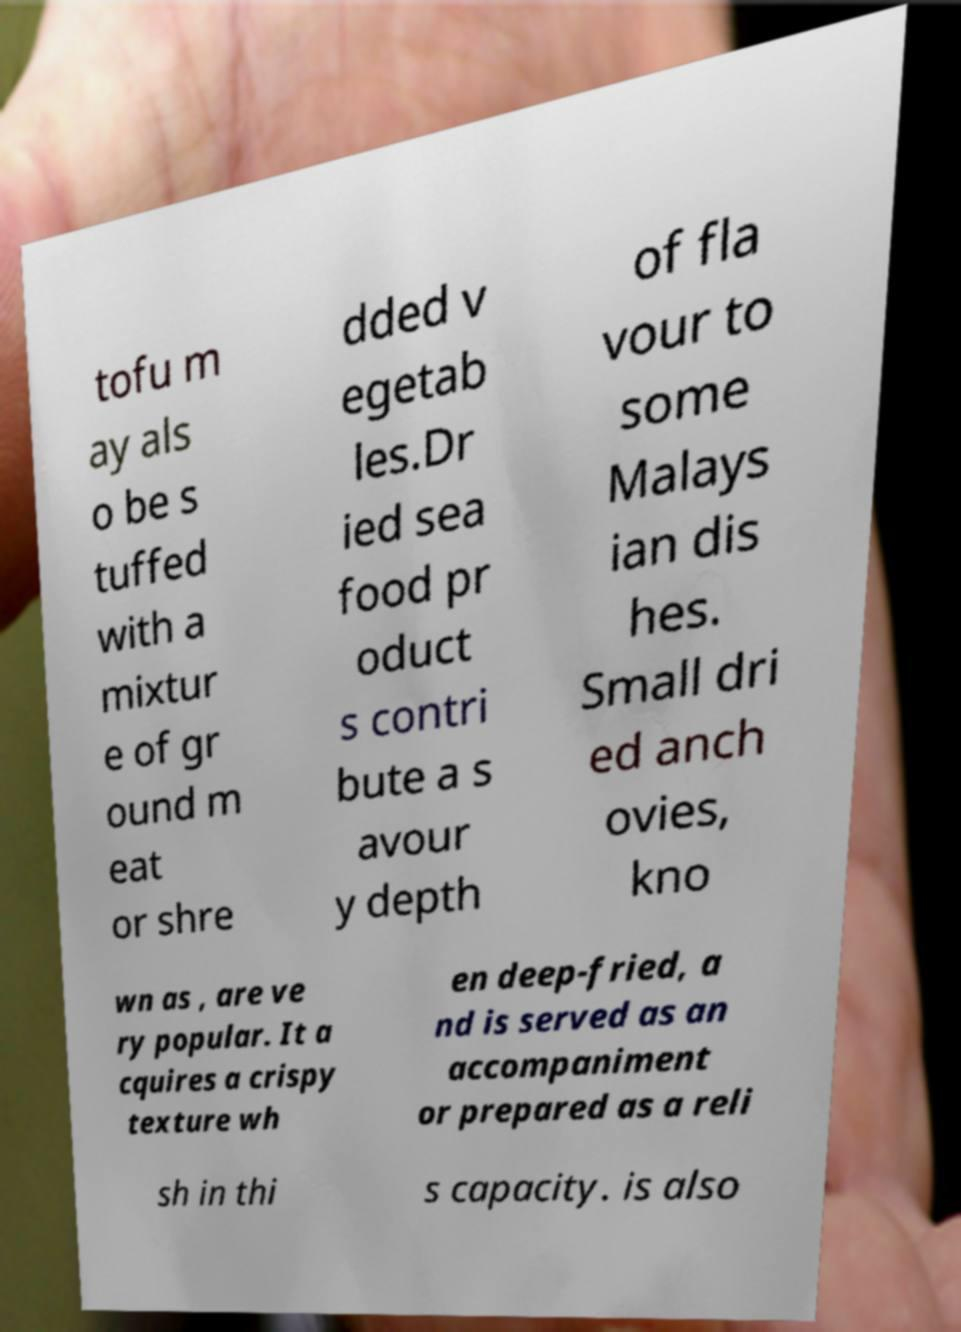Please read and relay the text visible in this image. What does it say? tofu m ay als o be s tuffed with a mixtur e of gr ound m eat or shre dded v egetab les.Dr ied sea food pr oduct s contri bute a s avour y depth of fla vour to some Malays ian dis hes. Small dri ed anch ovies, kno wn as , are ve ry popular. It a cquires a crispy texture wh en deep-fried, a nd is served as an accompaniment or prepared as a reli sh in thi s capacity. is also 